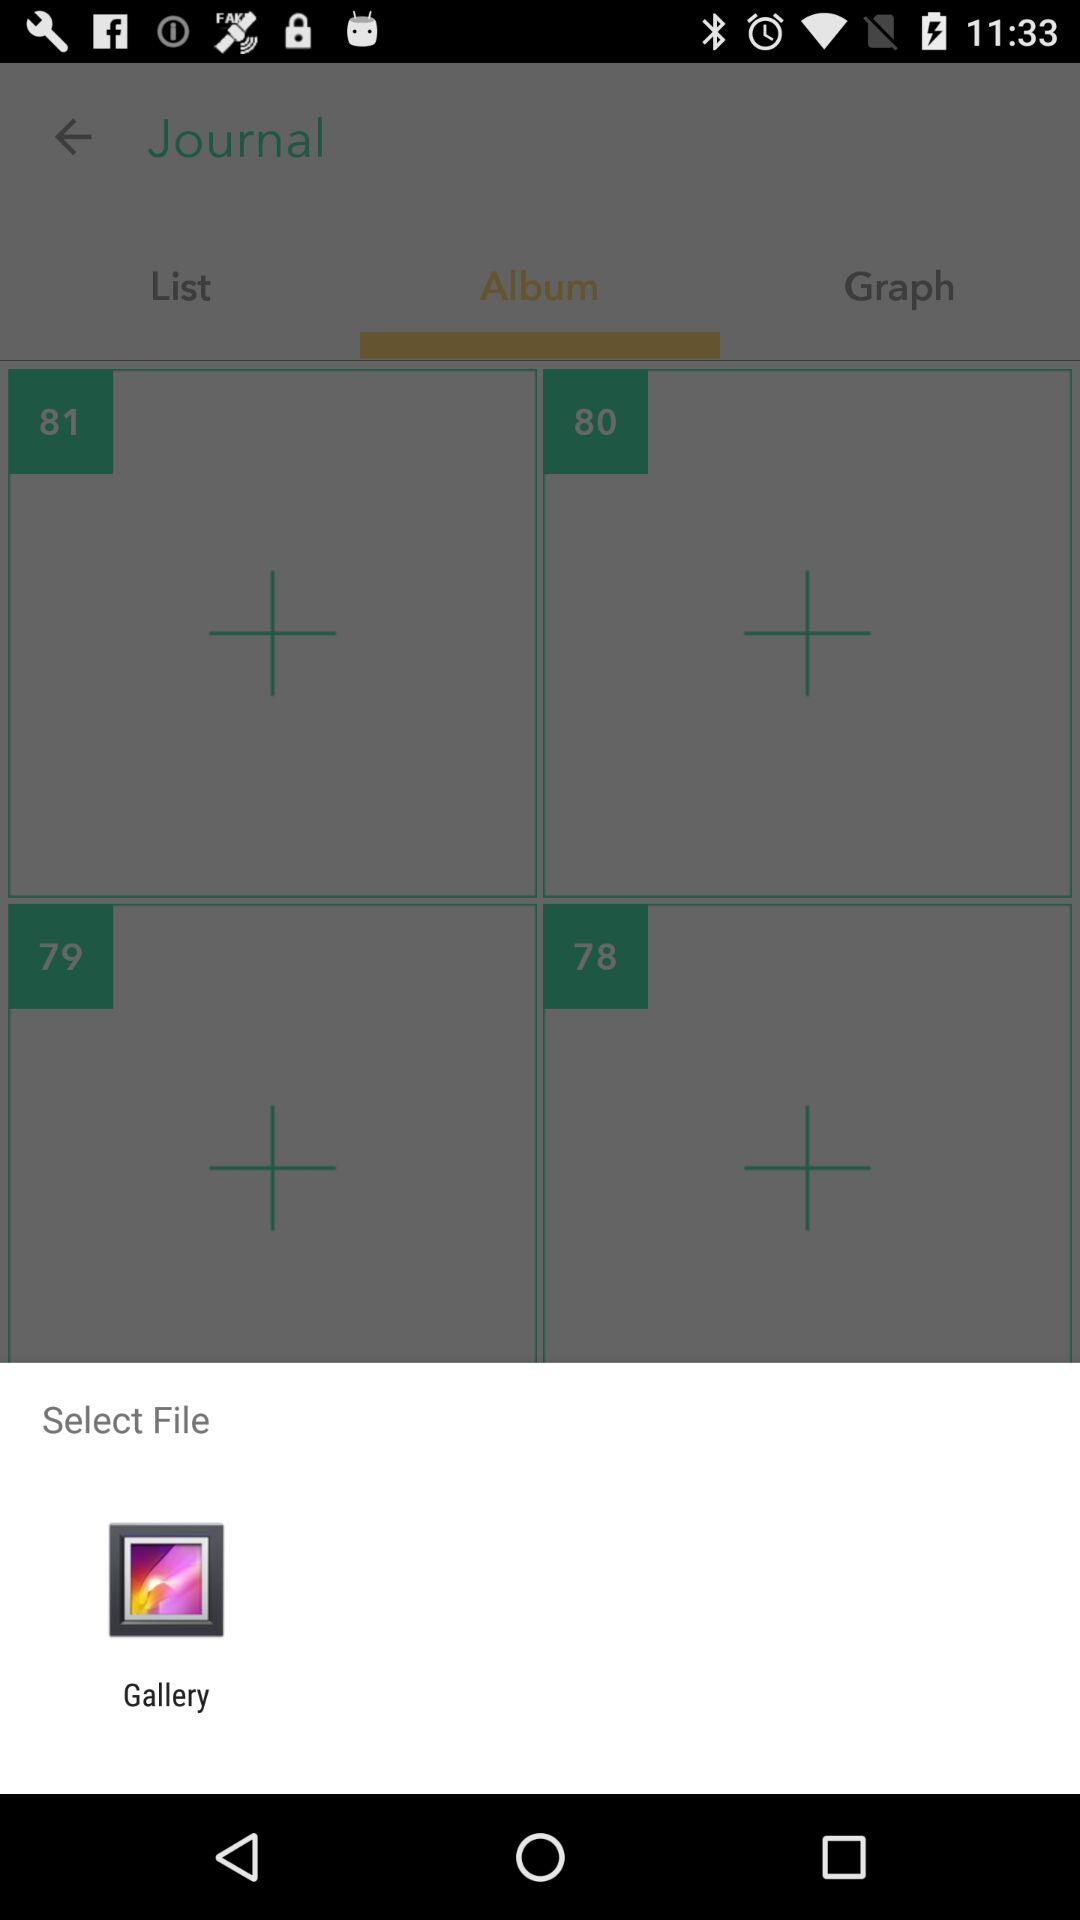Through what app can I select a file? You can select a file through the "Gallery" app. 